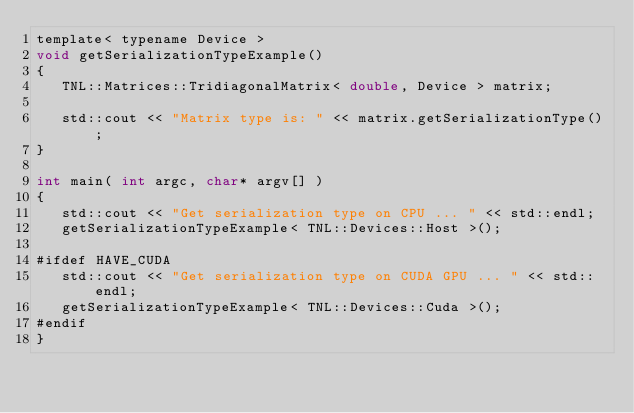<code> <loc_0><loc_0><loc_500><loc_500><_Cuda_>template< typename Device >
void getSerializationTypeExample()
{
   TNL::Matrices::TridiagonalMatrix< double, Device > matrix;

   std::cout << "Matrix type is: " << matrix.getSerializationType();
}

int main( int argc, char* argv[] )
{
   std::cout << "Get serialization type on CPU ... " << std::endl;
   getSerializationTypeExample< TNL::Devices::Host >();

#ifdef HAVE_CUDA
   std::cout << "Get serialization type on CUDA GPU ... " << std::endl;
   getSerializationTypeExample< TNL::Devices::Cuda >();
#endif
}
</code> 